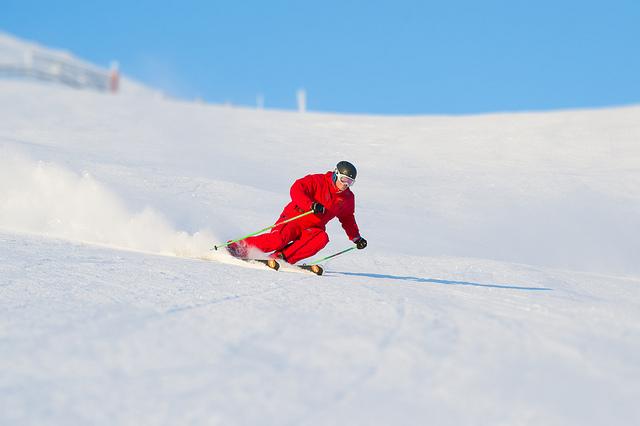Is the person moving quickly?
Concise answer only. Yes. Where is the man?
Keep it brief. Mountain. What color is this jacket?
Give a very brief answer. Red. What color is this person's outfit?
Quick response, please. Red. Does he have goggles on?
Give a very brief answer. Yes. Does the snow look rough?
Quick response, please. No. How many colors make up the person's outfit?
Give a very brief answer. 2. Is this person high in the air?
Be succinct. No. 